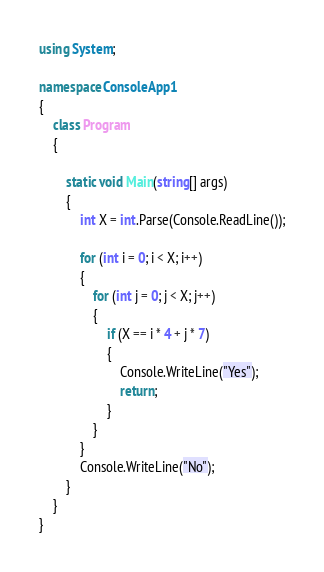<code> <loc_0><loc_0><loc_500><loc_500><_C#_>using System;

namespace ConsoleApp1
{
    class Program
    {
  
        static void Main(string[] args)
        {
            int X = int.Parse(Console.ReadLine());

            for (int i = 0; i < X; i++)
            {
                for (int j = 0; j < X; j++)
                {
                    if (X == i * 4 + j * 7)
                    {
                        Console.WriteLine("Yes");
                        return;
                    } 
                }
            }
            Console.WriteLine("No");
        }
    }
}
</code> 